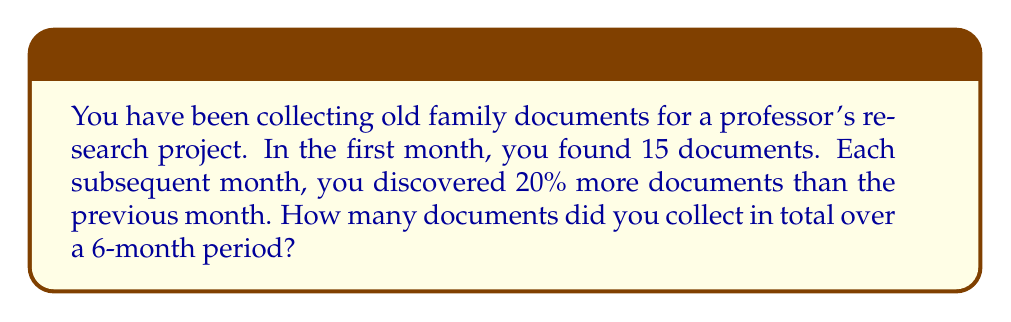Solve this math problem. Let's approach this step-by-step:

1) In the first month, you found 15 documents.

2) Each month after, you find 20% more than the previous month. This means we multiply the previous month's count by 1.20.

3) Let's calculate the number of documents for each month:

   Month 1: 15 documents
   Month 2: $15 \times 1.20 = 18$ documents
   Month 3: $18 \times 1.20 = 21.6$ documents
   Month 4: $21.6 \times 1.20 = 25.92$ documents
   Month 5: $25.92 \times 1.20 = 31.104$ documents
   Month 6: $31.104 \times 1.20 = 37.3248$ documents

4) Now, let's sum up all the documents:

   $$\text{Total} = 15 + 18 + 21.6 + 25.92 + 31.104 + 37.3248$$

5) Adding these up:

   $$\text{Total} = 148.9488$$

6) Since we're dealing with whole documents, we round down to the nearest integer:

   $$\text{Total} = 148$$

Therefore, over the 6-month period, you collected 148 documents in total.
Answer: 148 documents 